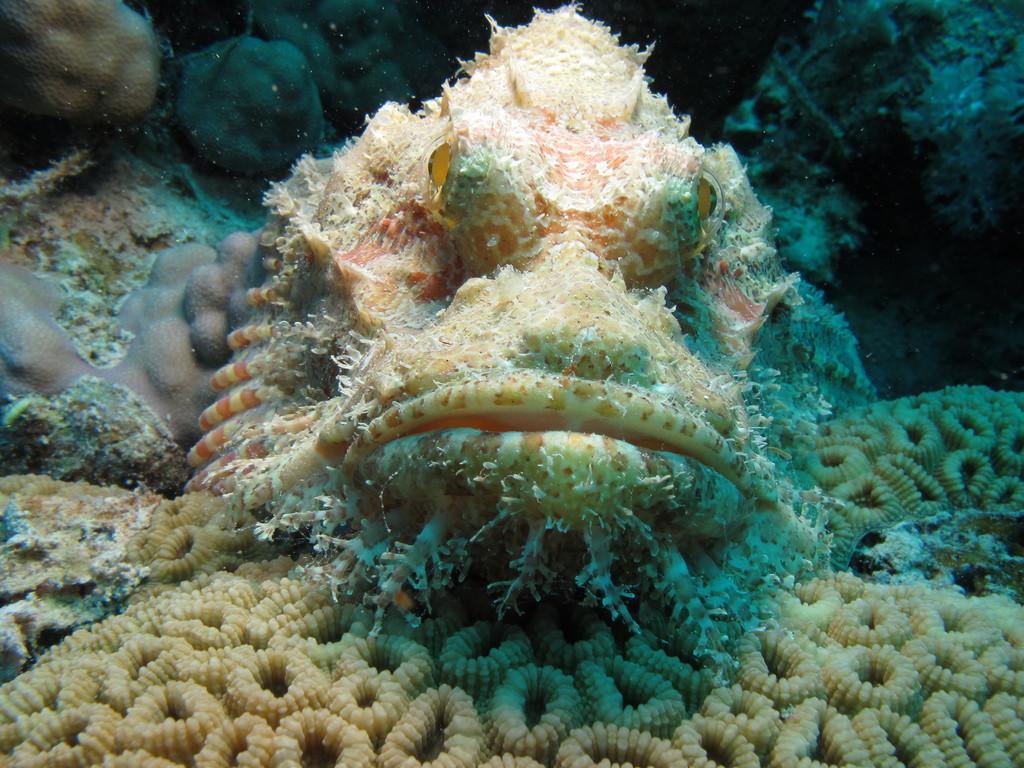Describe this image in one or two sentences. In this image in the foreground we can see some kind of living thing in the water. 